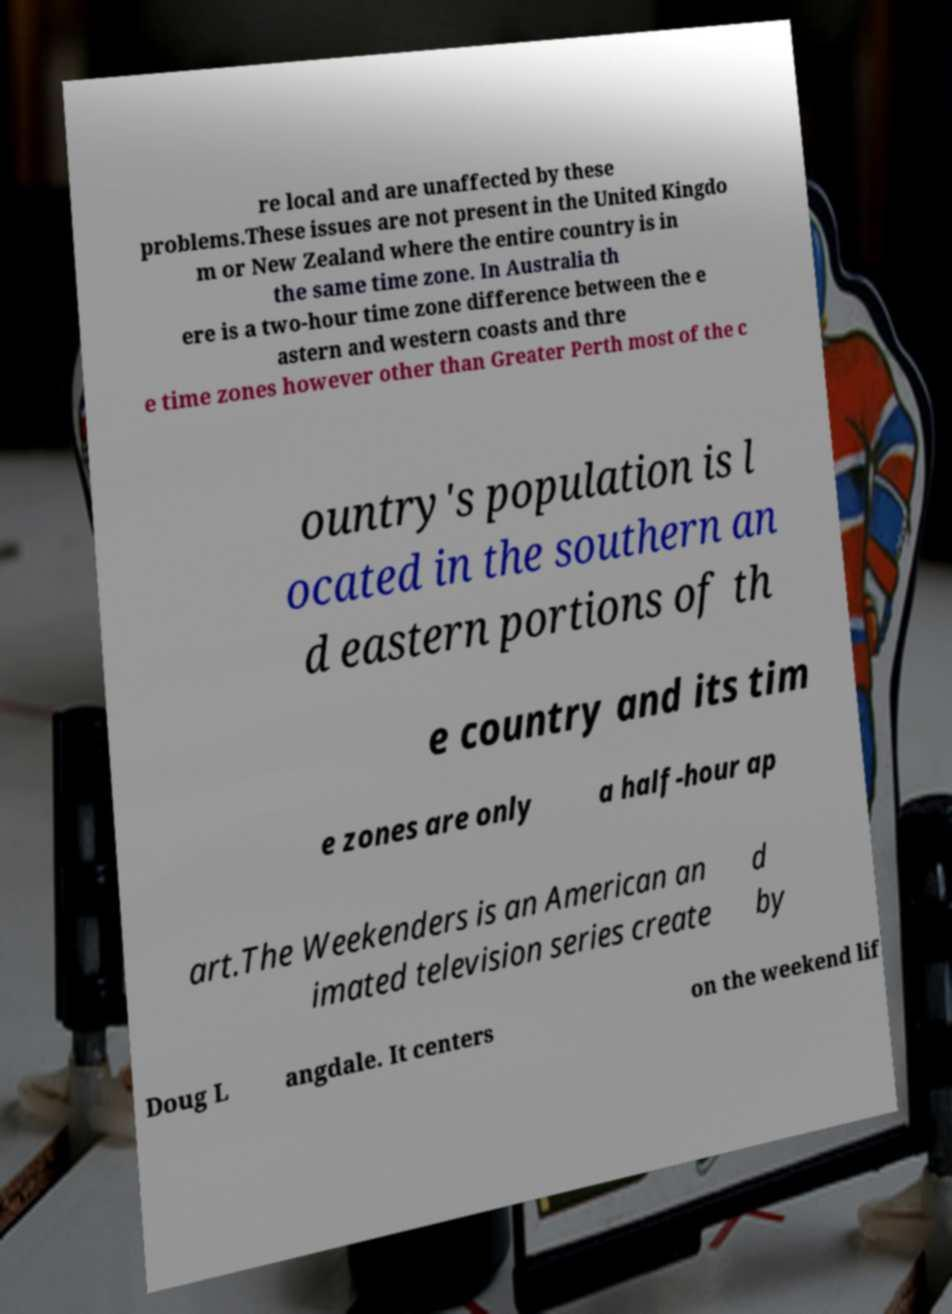There's text embedded in this image that I need extracted. Can you transcribe it verbatim? re local and are unaffected by these problems.These issues are not present in the United Kingdo m or New Zealand where the entire country is in the same time zone. In Australia th ere is a two-hour time zone difference between the e astern and western coasts and thre e time zones however other than Greater Perth most of the c ountry's population is l ocated in the southern an d eastern portions of th e country and its tim e zones are only a half-hour ap art.The Weekenders is an American an imated television series create d by Doug L angdale. It centers on the weekend lif 